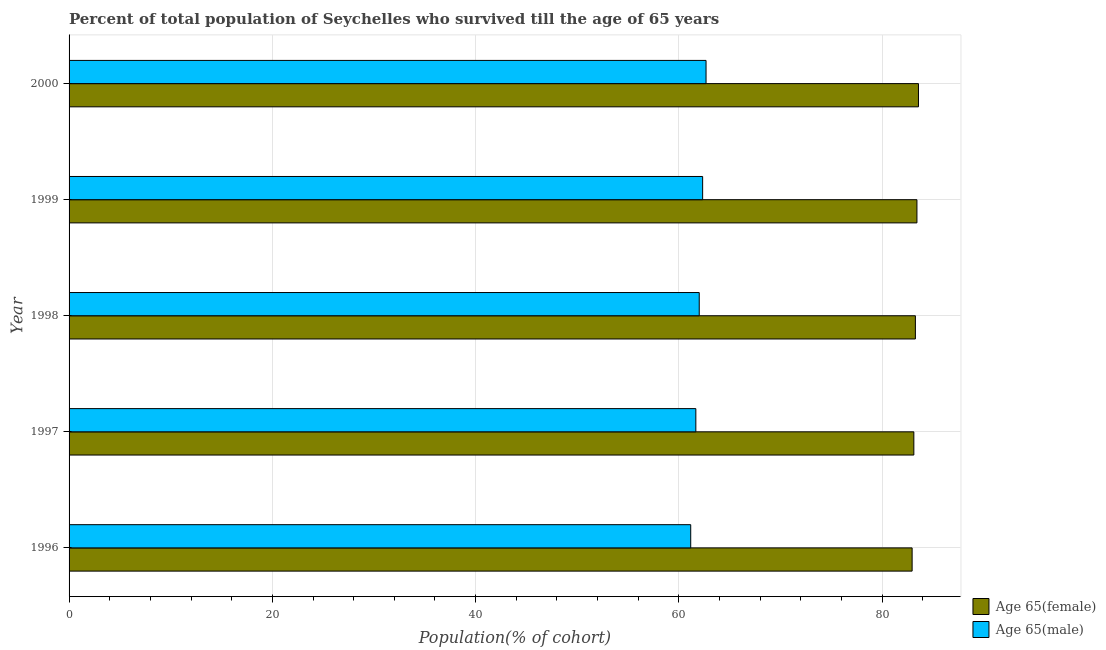How many different coloured bars are there?
Provide a succinct answer. 2. How many groups of bars are there?
Give a very brief answer. 5. Are the number of bars per tick equal to the number of legend labels?
Offer a terse response. Yes. What is the label of the 5th group of bars from the top?
Your answer should be very brief. 1996. In how many cases, is the number of bars for a given year not equal to the number of legend labels?
Keep it short and to the point. 0. What is the percentage of male population who survived till age of 65 in 1998?
Your response must be concise. 62. Across all years, what is the maximum percentage of female population who survived till age of 65?
Your answer should be compact. 83.57. Across all years, what is the minimum percentage of female population who survived till age of 65?
Offer a terse response. 82.94. In which year was the percentage of male population who survived till age of 65 maximum?
Your response must be concise. 2000. In which year was the percentage of male population who survived till age of 65 minimum?
Offer a very short reply. 1996. What is the total percentage of female population who survived till age of 65 in the graph?
Offer a very short reply. 416.29. What is the difference between the percentage of male population who survived till age of 65 in 1998 and that in 1999?
Offer a very short reply. -0.34. What is the difference between the percentage of female population who survived till age of 65 in 2000 and the percentage of male population who survived till age of 65 in 1996?
Keep it short and to the point. 22.41. What is the average percentage of female population who survived till age of 65 per year?
Provide a short and direct response. 83.26. In the year 1996, what is the difference between the percentage of male population who survived till age of 65 and percentage of female population who survived till age of 65?
Give a very brief answer. -21.78. In how many years, is the percentage of female population who survived till age of 65 greater than 56 %?
Your answer should be compact. 5. Is the percentage of male population who survived till age of 65 in 1996 less than that in 1999?
Your response must be concise. Yes. What is the difference between the highest and the second highest percentage of female population who survived till age of 65?
Keep it short and to the point. 0.15. What is the difference between the highest and the lowest percentage of female population who survived till age of 65?
Your response must be concise. 0.62. In how many years, is the percentage of female population who survived till age of 65 greater than the average percentage of female population who survived till age of 65 taken over all years?
Offer a terse response. 3. Is the sum of the percentage of female population who survived till age of 65 in 1996 and 1998 greater than the maximum percentage of male population who survived till age of 65 across all years?
Your answer should be very brief. Yes. What does the 1st bar from the top in 1996 represents?
Ensure brevity in your answer.  Age 65(male). What does the 2nd bar from the bottom in 1999 represents?
Give a very brief answer. Age 65(male). How many bars are there?
Offer a terse response. 10. Are all the bars in the graph horizontal?
Provide a short and direct response. Yes. What is the difference between two consecutive major ticks on the X-axis?
Your answer should be compact. 20. Does the graph contain grids?
Your response must be concise. Yes. What is the title of the graph?
Provide a short and direct response. Percent of total population of Seychelles who survived till the age of 65 years. Does "% of gross capital formation" appear as one of the legend labels in the graph?
Make the answer very short. No. What is the label or title of the X-axis?
Your answer should be very brief. Population(% of cohort). What is the label or title of the Y-axis?
Offer a very short reply. Year. What is the Population(% of cohort) in Age 65(female) in 1996?
Your answer should be compact. 82.94. What is the Population(% of cohort) in Age 65(male) in 1996?
Offer a terse response. 61.16. What is the Population(% of cohort) of Age 65(female) in 1997?
Offer a very short reply. 83.11. What is the Population(% of cohort) of Age 65(male) in 1997?
Ensure brevity in your answer.  61.66. What is the Population(% of cohort) of Age 65(female) in 1998?
Your response must be concise. 83.26. What is the Population(% of cohort) of Age 65(male) in 1998?
Ensure brevity in your answer.  62. What is the Population(% of cohort) in Age 65(female) in 1999?
Provide a succinct answer. 83.41. What is the Population(% of cohort) in Age 65(male) in 1999?
Make the answer very short. 62.33. What is the Population(% of cohort) of Age 65(female) in 2000?
Offer a terse response. 83.57. What is the Population(% of cohort) of Age 65(male) in 2000?
Provide a short and direct response. 62.67. Across all years, what is the maximum Population(% of cohort) of Age 65(female)?
Your answer should be very brief. 83.57. Across all years, what is the maximum Population(% of cohort) in Age 65(male)?
Make the answer very short. 62.67. Across all years, what is the minimum Population(% of cohort) in Age 65(female)?
Provide a succinct answer. 82.94. Across all years, what is the minimum Population(% of cohort) in Age 65(male)?
Your response must be concise. 61.16. What is the total Population(% of cohort) in Age 65(female) in the graph?
Provide a short and direct response. 416.29. What is the total Population(% of cohort) in Age 65(male) in the graph?
Your answer should be compact. 309.82. What is the difference between the Population(% of cohort) of Age 65(female) in 1996 and that in 1997?
Make the answer very short. -0.17. What is the difference between the Population(% of cohort) in Age 65(male) in 1996 and that in 1997?
Provide a short and direct response. -0.5. What is the difference between the Population(% of cohort) in Age 65(female) in 1996 and that in 1998?
Offer a terse response. -0.32. What is the difference between the Population(% of cohort) of Age 65(male) in 1996 and that in 1998?
Provide a succinct answer. -0.84. What is the difference between the Population(% of cohort) of Age 65(female) in 1996 and that in 1999?
Your answer should be compact. -0.47. What is the difference between the Population(% of cohort) in Age 65(male) in 1996 and that in 1999?
Your answer should be compact. -1.17. What is the difference between the Population(% of cohort) of Age 65(female) in 1996 and that in 2000?
Offer a very short reply. -0.62. What is the difference between the Population(% of cohort) of Age 65(male) in 1996 and that in 2000?
Keep it short and to the point. -1.51. What is the difference between the Population(% of cohort) in Age 65(female) in 1997 and that in 1998?
Offer a terse response. -0.15. What is the difference between the Population(% of cohort) in Age 65(male) in 1997 and that in 1998?
Keep it short and to the point. -0.33. What is the difference between the Population(% of cohort) in Age 65(female) in 1997 and that in 1999?
Provide a short and direct response. -0.3. What is the difference between the Population(% of cohort) of Age 65(male) in 1997 and that in 1999?
Provide a short and direct response. -0.67. What is the difference between the Population(% of cohort) of Age 65(female) in 1997 and that in 2000?
Keep it short and to the point. -0.46. What is the difference between the Population(% of cohort) of Age 65(male) in 1997 and that in 2000?
Make the answer very short. -1. What is the difference between the Population(% of cohort) of Age 65(female) in 1998 and that in 1999?
Provide a short and direct response. -0.15. What is the difference between the Population(% of cohort) in Age 65(male) in 1998 and that in 1999?
Provide a short and direct response. -0.33. What is the difference between the Population(% of cohort) in Age 65(female) in 1998 and that in 2000?
Your answer should be compact. -0.3. What is the difference between the Population(% of cohort) in Age 65(male) in 1998 and that in 2000?
Offer a terse response. -0.67. What is the difference between the Population(% of cohort) in Age 65(female) in 1999 and that in 2000?
Give a very brief answer. -0.15. What is the difference between the Population(% of cohort) in Age 65(male) in 1999 and that in 2000?
Give a very brief answer. -0.33. What is the difference between the Population(% of cohort) in Age 65(female) in 1996 and the Population(% of cohort) in Age 65(male) in 1997?
Provide a succinct answer. 21.28. What is the difference between the Population(% of cohort) of Age 65(female) in 1996 and the Population(% of cohort) of Age 65(male) in 1998?
Your response must be concise. 20.94. What is the difference between the Population(% of cohort) of Age 65(female) in 1996 and the Population(% of cohort) of Age 65(male) in 1999?
Provide a succinct answer. 20.61. What is the difference between the Population(% of cohort) in Age 65(female) in 1996 and the Population(% of cohort) in Age 65(male) in 2000?
Make the answer very short. 20.27. What is the difference between the Population(% of cohort) in Age 65(female) in 1997 and the Population(% of cohort) in Age 65(male) in 1998?
Provide a short and direct response. 21.11. What is the difference between the Population(% of cohort) in Age 65(female) in 1997 and the Population(% of cohort) in Age 65(male) in 1999?
Give a very brief answer. 20.78. What is the difference between the Population(% of cohort) in Age 65(female) in 1997 and the Population(% of cohort) in Age 65(male) in 2000?
Offer a very short reply. 20.44. What is the difference between the Population(% of cohort) of Age 65(female) in 1998 and the Population(% of cohort) of Age 65(male) in 1999?
Ensure brevity in your answer.  20.93. What is the difference between the Population(% of cohort) in Age 65(female) in 1998 and the Population(% of cohort) in Age 65(male) in 2000?
Your answer should be compact. 20.6. What is the difference between the Population(% of cohort) of Age 65(female) in 1999 and the Population(% of cohort) of Age 65(male) in 2000?
Your response must be concise. 20.75. What is the average Population(% of cohort) in Age 65(female) per year?
Provide a succinct answer. 83.26. What is the average Population(% of cohort) in Age 65(male) per year?
Ensure brevity in your answer.  61.96. In the year 1996, what is the difference between the Population(% of cohort) of Age 65(female) and Population(% of cohort) of Age 65(male)?
Your answer should be very brief. 21.78. In the year 1997, what is the difference between the Population(% of cohort) in Age 65(female) and Population(% of cohort) in Age 65(male)?
Keep it short and to the point. 21.45. In the year 1998, what is the difference between the Population(% of cohort) of Age 65(female) and Population(% of cohort) of Age 65(male)?
Offer a very short reply. 21.26. In the year 1999, what is the difference between the Population(% of cohort) in Age 65(female) and Population(% of cohort) in Age 65(male)?
Give a very brief answer. 21.08. In the year 2000, what is the difference between the Population(% of cohort) in Age 65(female) and Population(% of cohort) in Age 65(male)?
Offer a very short reply. 20.9. What is the ratio of the Population(% of cohort) in Age 65(male) in 1996 to that in 1997?
Ensure brevity in your answer.  0.99. What is the ratio of the Population(% of cohort) in Age 65(female) in 1996 to that in 1998?
Your answer should be very brief. 1. What is the ratio of the Population(% of cohort) of Age 65(male) in 1996 to that in 1998?
Your response must be concise. 0.99. What is the ratio of the Population(% of cohort) of Age 65(female) in 1996 to that in 1999?
Provide a short and direct response. 0.99. What is the ratio of the Population(% of cohort) of Age 65(male) in 1996 to that in 1999?
Keep it short and to the point. 0.98. What is the ratio of the Population(% of cohort) of Age 65(male) in 1996 to that in 2000?
Your response must be concise. 0.98. What is the ratio of the Population(% of cohort) in Age 65(female) in 1997 to that in 1998?
Provide a succinct answer. 1. What is the ratio of the Population(% of cohort) in Age 65(male) in 1997 to that in 1998?
Ensure brevity in your answer.  0.99. What is the ratio of the Population(% of cohort) of Age 65(female) in 1997 to that in 1999?
Make the answer very short. 1. What is the ratio of the Population(% of cohort) of Age 65(male) in 1997 to that in 1999?
Your answer should be compact. 0.99. What is the ratio of the Population(% of cohort) in Age 65(male) in 1998 to that in 1999?
Provide a succinct answer. 0.99. What is the ratio of the Population(% of cohort) of Age 65(female) in 1998 to that in 2000?
Your response must be concise. 1. What is the ratio of the Population(% of cohort) in Age 65(male) in 1998 to that in 2000?
Make the answer very short. 0.99. What is the difference between the highest and the second highest Population(% of cohort) in Age 65(female)?
Offer a terse response. 0.15. What is the difference between the highest and the second highest Population(% of cohort) in Age 65(male)?
Offer a terse response. 0.33. What is the difference between the highest and the lowest Population(% of cohort) of Age 65(female)?
Make the answer very short. 0.62. What is the difference between the highest and the lowest Population(% of cohort) of Age 65(male)?
Keep it short and to the point. 1.51. 